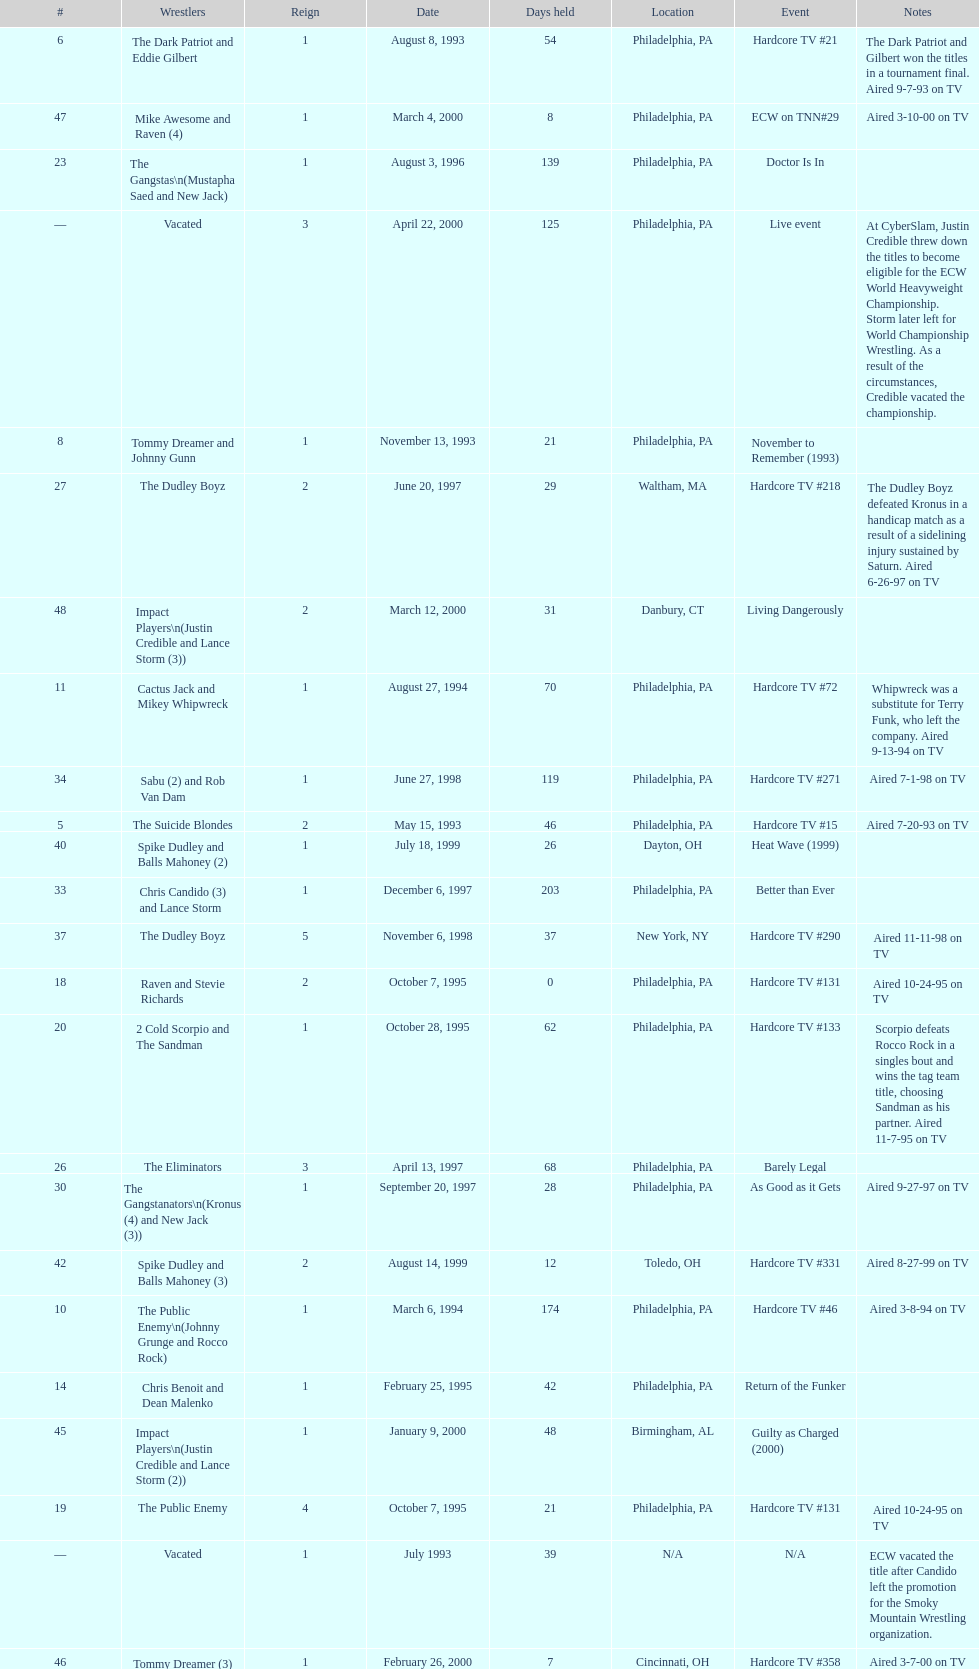What is the total days held on # 1st? 283. 